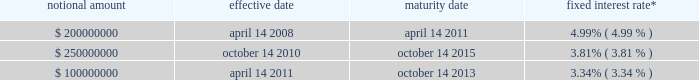( v ) bankruptcy , insolvency , or other similar proceedings , ( vi ) our inability to pay debts , ( vii ) judgment defaults of $ 15 million or more , ( viii ) customary erisa and environmental defaults , ( ix ) actual or asserted invalidity of any material provision of the loan documentation or impairment of a portion of the collateral , ( x ) failure of subordinated indebtedness to be validly and sufficiently subordinated , and ( xi ) a change of control .
Borrowings under the credit agreement accrue interest at variable rates , which depend on the type ( u.s .
Dollar or canadian dollar ) and duration of the borrowing , plus an applicable margin rate .
The weighted-average interest rates , including the effect of interest rate swap agreements , on borrowings outstanding against our senior secured credit facility at december 31 , 2010 and 2009 were 3.97% ( 3.97 % ) and 4.53% ( 4.53 % ) , respectively .
Borrowings against the senior secured credit facility totaled $ 590.1 million and $ 595.7 million at december 31 , 2010 and 2009 , respectively , of which $ 50.0 million and $ 7.5 million were classified as current maturities , respectively .
We also incur commitment fees on the unused portion of our revolving credit facility ranging from 0.38% ( 0.38 % ) to 0.50% ( 0.50 % ) .
As part of the consideration for business acquisitions completed during 2010 , 2009 and 2008 , we issued promissory notes totaling approximately $ 5.5 million , $ 1.2 million and $ 1.6 million , respectively .
The notes bear interest at annual rates of 2.0% ( 2.0 % ) to 4.0% ( 4.0 % ) , and interest is payable at maturity or in monthly installments .
Note 6 .
Derivative instruments and hedging activities we are exposed to market risks , including the effect of changes in interest rates , foreign currency exchange rates and commodity prices .
Under our current policies , we use derivatives to manage our exposure to variable interest rates on our credit agreement , but we do not attempt to hedge our foreign currency and commodity price risks .
We do not hold or issue derivatives for trading purposes .
At december 31 , 2010 , we had interest rate swap agreements in place to hedge a portion of the variable interest rate risk on our variable rate term loans , with the objective of minimizing the impact of interest rate fluctuations and stabilizing cash flows .
Beginning on the effective dates of the interest rate swap agreements , on a monthly basis through the maturity date , we have paid and will pay the fixed interest rate and have received and will receive payment at a variable rate of interest based on the london interbank offered rate ( 201clibor 201d ) on the notional amount .
The interest rate swap agreements qualify as cash flow hedges , and we have elected to apply hedge accounting for these swap agreements .
As a result , the effective portion of changes in the fair value of the interest rate swap agreements is recorded in other comprehensive income and is reclassified to interest expense when the underlying interest payment has an impact on earnings .
The ineffective portion of changes in the fair value of the interest rate swap agreements is reported in interest expense .
The table summarizes the terms of our interest rate swap agreements as of december 31 , 2010: .
* includes applicable margin of 2.25% ( 2.25 % ) per annum currently in effect under the credit agreement as of december 31 , 2010 , the fair market value of the $ 200 million notional amount swap was a liability of $ 1.4 million , included in other accrued expenses on our consolidated balance sheet .
The fair market value of the other swap contracts was an asset of $ 4.8 million , included in other assets on our consolidated balance sheet as of december 31 , 2010 .
As of december 31 , 2009 , the fair market value of the interest rate swap contracts was a liability of $ 10.2 million and was included in other accrued expenses ( $ 5.0 million ) and other noncurrent liabilities ( $ 5.2 million ) on our consolidated balance sheet. .
What was the sum of the promissory notes totaling approximately issued as part of the plan business acquisitions from 2008 to 2010 in millions? 
Computations: ((5.5 + 1.2) + 1.6)
Answer: 8.3. 